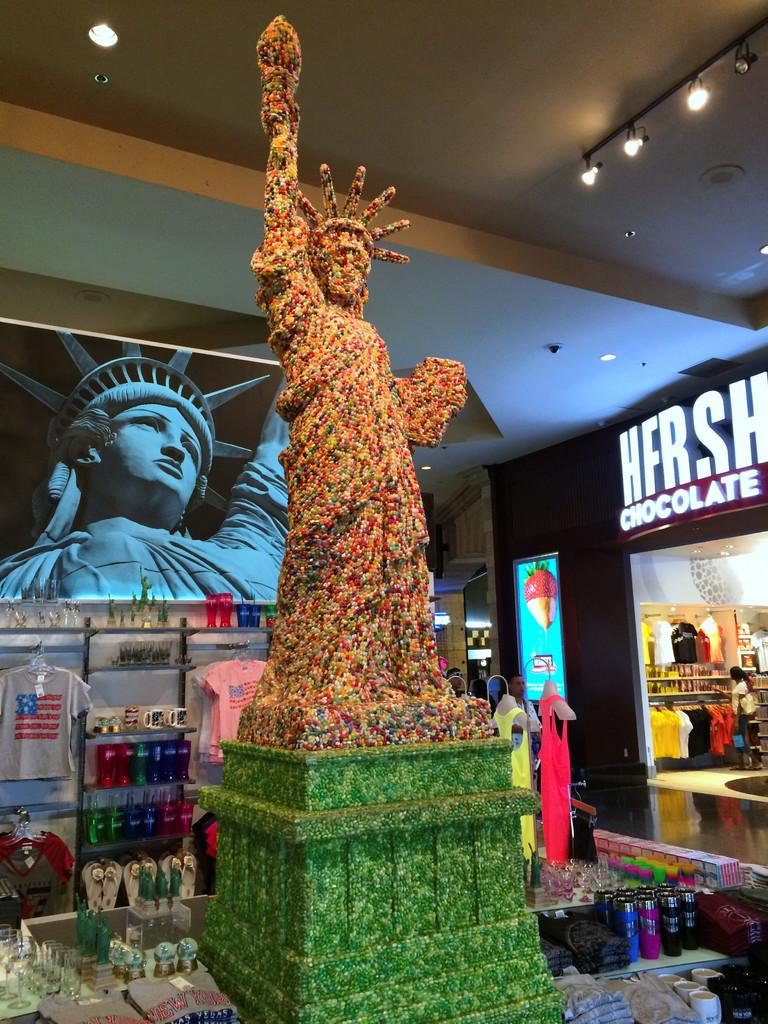What is the main subject of the image? There is a statue of liberty in the image. What else can be seen around the statue? There are objects around the statue. What additional element is present in the image? There is a banner visible in the image. What is located on the right side of the image? There is a showroom on the right side of the image. What line is the statue of liberty standing in the image? The statue of liberty is not standing in a line in the image; it is a stationary object. What act is the statue of liberty performing in the image? The statue of liberty is not performing any act in the image; it is a stationary object. 